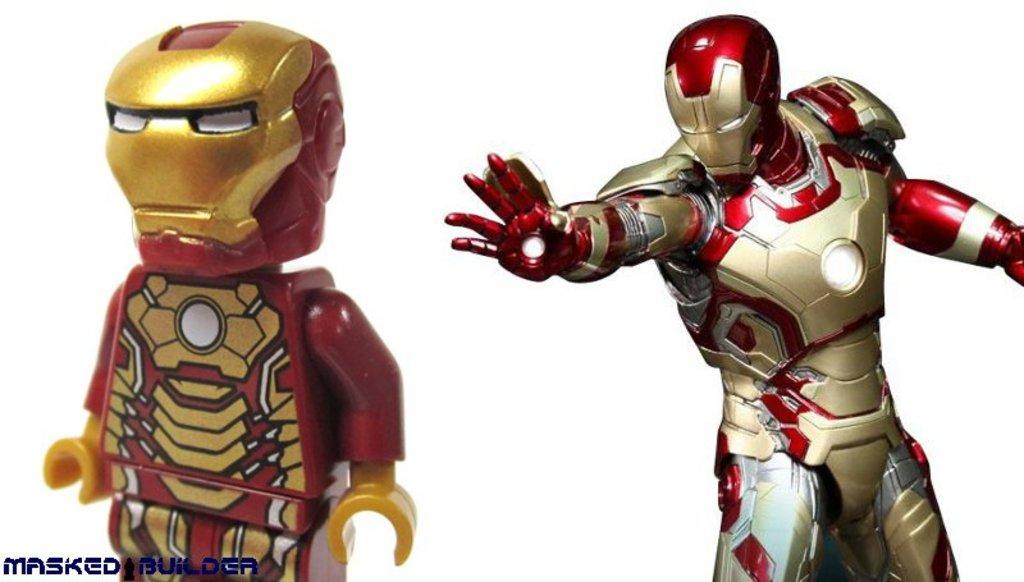What objects are present in the image that can be classified as toys? There are two toys in the image. What type of toys are they? Both toys belong to the same category. What is the mass of the toys in the image? The mass of the toys cannot be determined from the image alone, as it does not provide any information about their size or weight. 